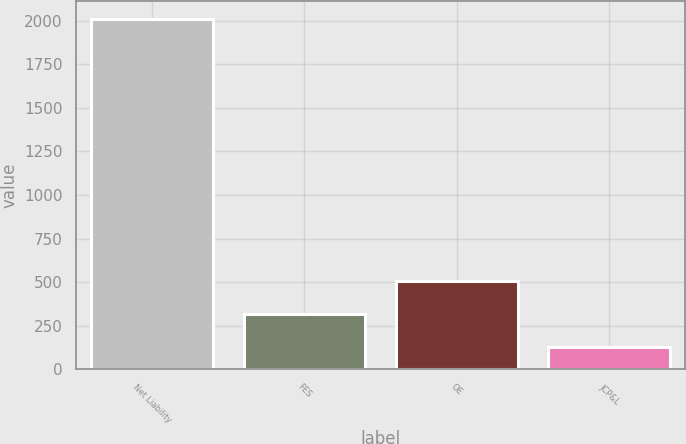Convert chart to OTSL. <chart><loc_0><loc_0><loc_500><loc_500><bar_chart><fcel>Net Liability<fcel>FES<fcel>OE<fcel>JCP&L<nl><fcel>2012<fcel>318.2<fcel>506.4<fcel>130<nl></chart> 